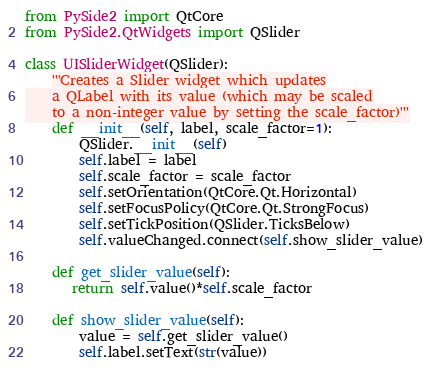<code> <loc_0><loc_0><loc_500><loc_500><_Python_>from PySide2 import QtCore
from PySide2.QtWidgets import QSlider

class UISliderWidget(QSlider):
    '''Creates a Slider widget which updates
    a QLabel with its value (which may be scaled
    to a non-integer value by setting the scale_factor)'''
    def __init__(self, label, scale_factor=1):
        QSlider.__init__(self)
        self.label = label
        self.scale_factor = scale_factor
        self.setOrientation(QtCore.Qt.Horizontal)
        self.setFocusPolicy(QtCore.Qt.StrongFocus) 
        self.setTickPosition(QSlider.TicksBelow) 
        self.valueChanged.connect(self.show_slider_value)

    def get_slider_value(self):
       return self.value()*self.scale_factor

    def show_slider_value(self):
        value = self.get_slider_value()
        self.label.setText(str(value))</code> 